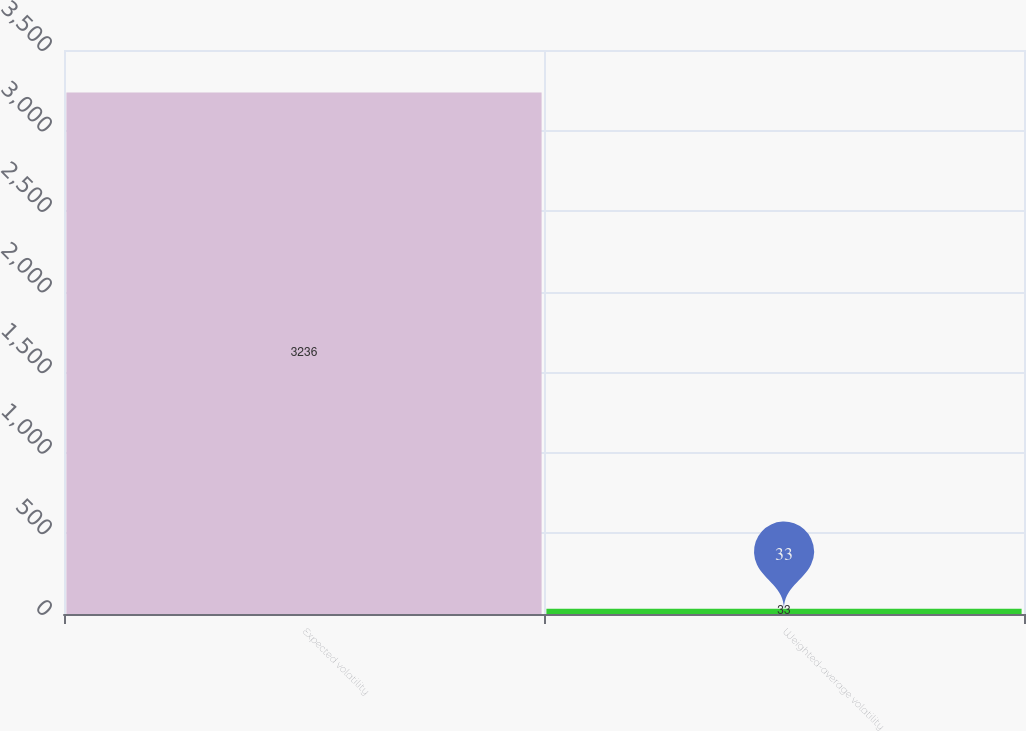Convert chart. <chart><loc_0><loc_0><loc_500><loc_500><bar_chart><fcel>Expected volatility<fcel>Weighted-average volatility<nl><fcel>3236<fcel>33<nl></chart> 